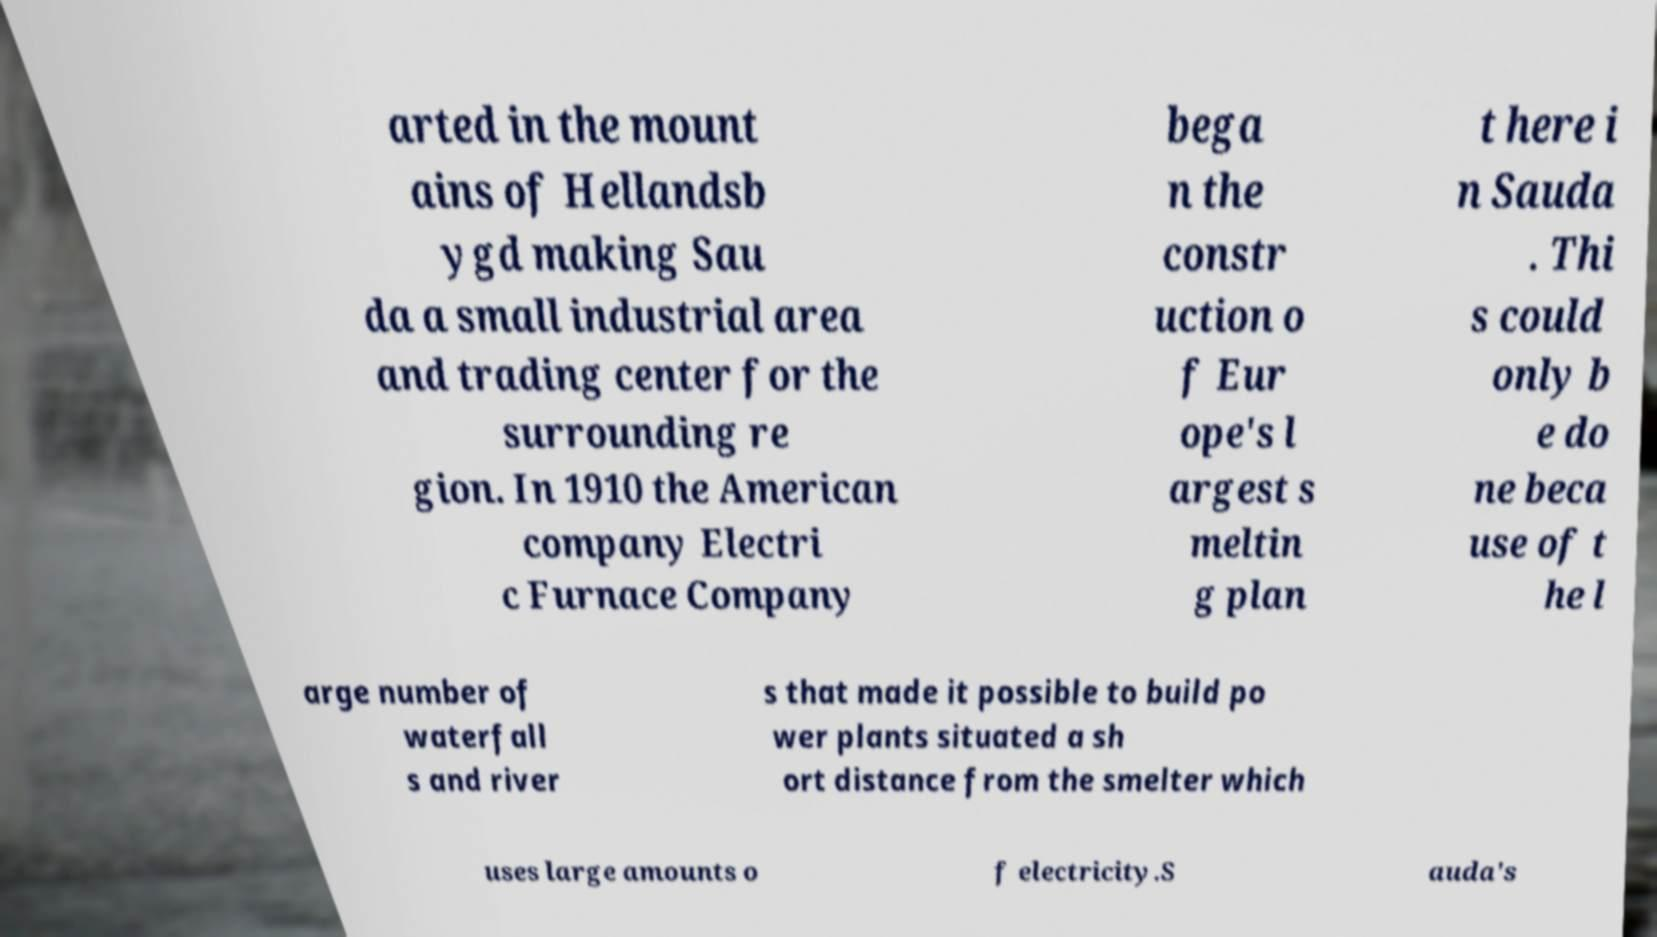There's text embedded in this image that I need extracted. Can you transcribe it verbatim? arted in the mount ains of Hellandsb ygd making Sau da a small industrial area and trading center for the surrounding re gion. In 1910 the American company Electri c Furnace Company bega n the constr uction o f Eur ope's l argest s meltin g plan t here i n Sauda . Thi s could only b e do ne beca use of t he l arge number of waterfall s and river s that made it possible to build po wer plants situated a sh ort distance from the smelter which uses large amounts o f electricity.S auda's 